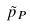<formula> <loc_0><loc_0><loc_500><loc_500>\tilde { p } _ { P }</formula> 